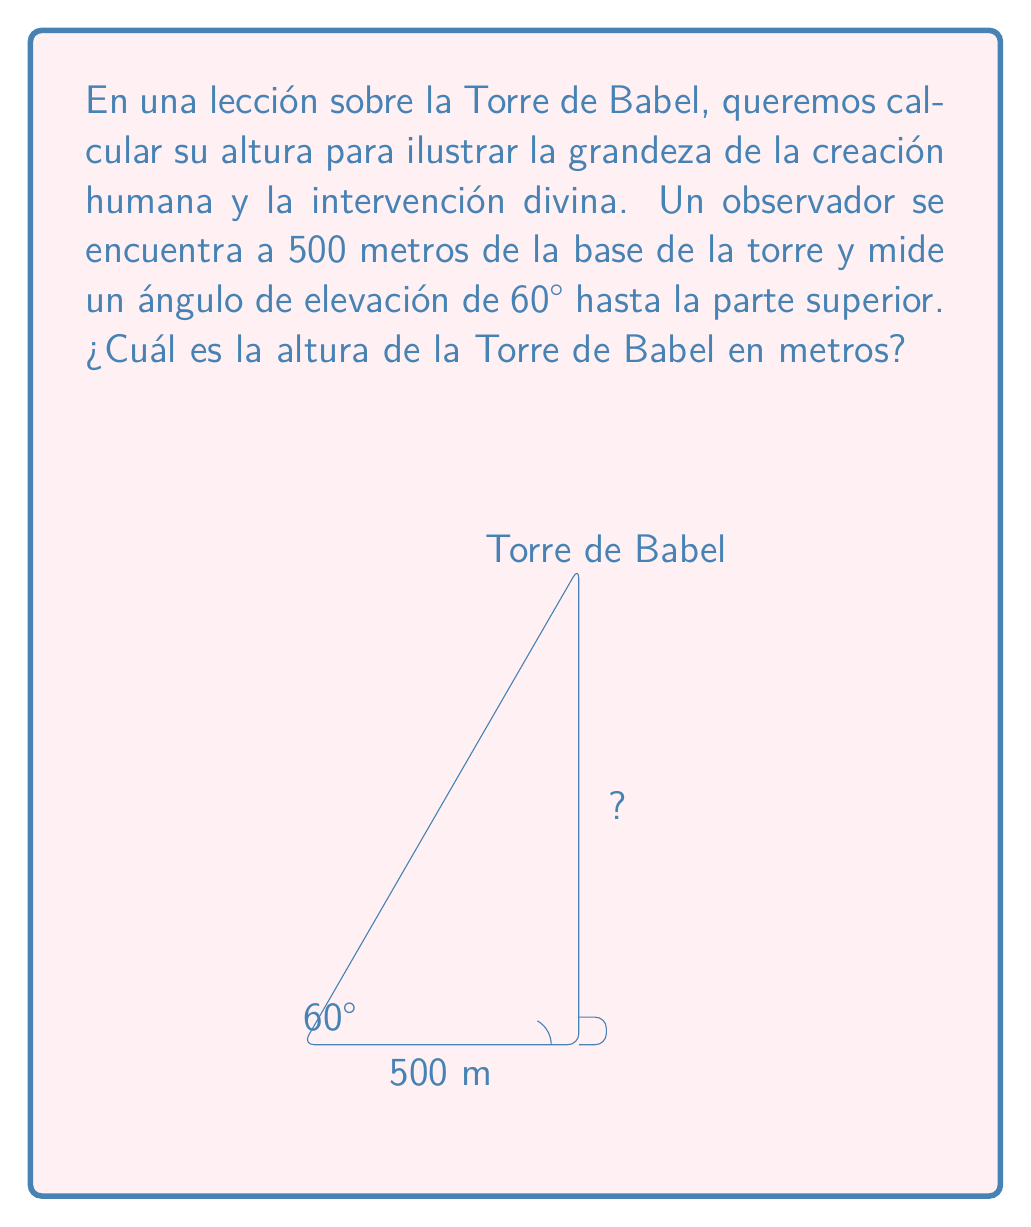Can you answer this question? Para resolver este problema, utilizaremos la trigonometría, específicamente la función tangente. Recordemos que la tangente de un ángulo en un triángulo rectángulo es igual al cateto opuesto dividido por el cateto adyacente.

1) En nuestro caso, el ángulo de elevación es de 60°, y el cateto adyacente (la distancia desde el observador hasta la base de la torre) es de 500 metros.

2) Llamemos h a la altura de la torre. Entonces:

   $$\tan(60°) = \frac{h}{500}$$

3) Sabemos que $\tan(60°) = \sqrt{3}$. Sustituyendo:

   $$\sqrt{3} = \frac{h}{500}$$

4) Multiplicamos ambos lados por 500:

   $$500\sqrt{3} = h$$

5) Calculamos el valor de $500\sqrt{3}$:

   $$h = 500 * 1.732050808 \approx 866.03$$

Por lo tanto, la altura de la Torre de Babel es aproximadamente 866.03 metros.

Esta altura nos ayuda a comprender la magnitud de la empresa humana en la construcción de la Torre de Babel, y por qué Dios intervino para detener su construcción, como se narra en Génesis 11:1-9.
Answer: La altura de la Torre de Babel es aproximadamente 866.03 metros. 